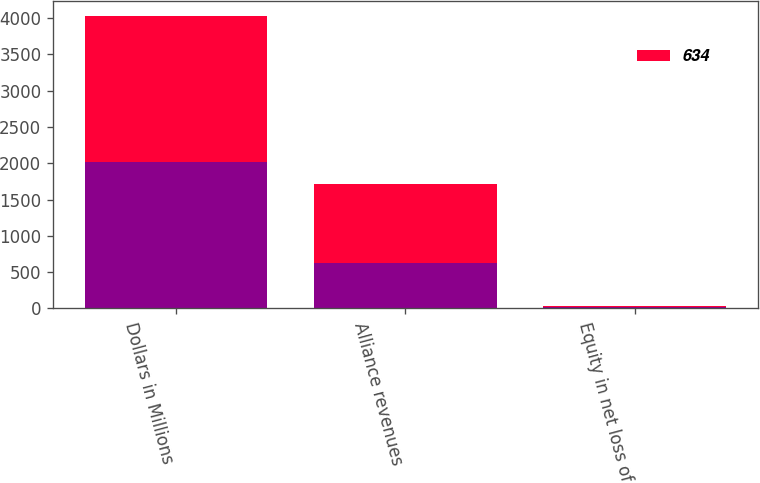Convert chart to OTSL. <chart><loc_0><loc_0><loc_500><loc_500><stacked_bar_chart><ecel><fcel>Dollars in Millions<fcel>Alliance revenues<fcel>Equity in net loss of<nl><fcel>nan<fcel>2017<fcel>623<fcel>13<nl><fcel>634<fcel>2015<fcel>1096<fcel>17<nl></chart> 